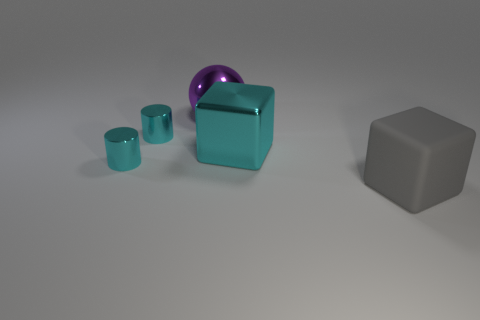What is the color of the thing that is both in front of the big cyan cube and on the left side of the large cyan object? In the image, the object located both in front of the large cyan cube and to the left of the cyan object is a small cyan cylinder. Its color is the same cyan hue as the larger cube and object, exhibiting consistency in coloration among the items depicted. 